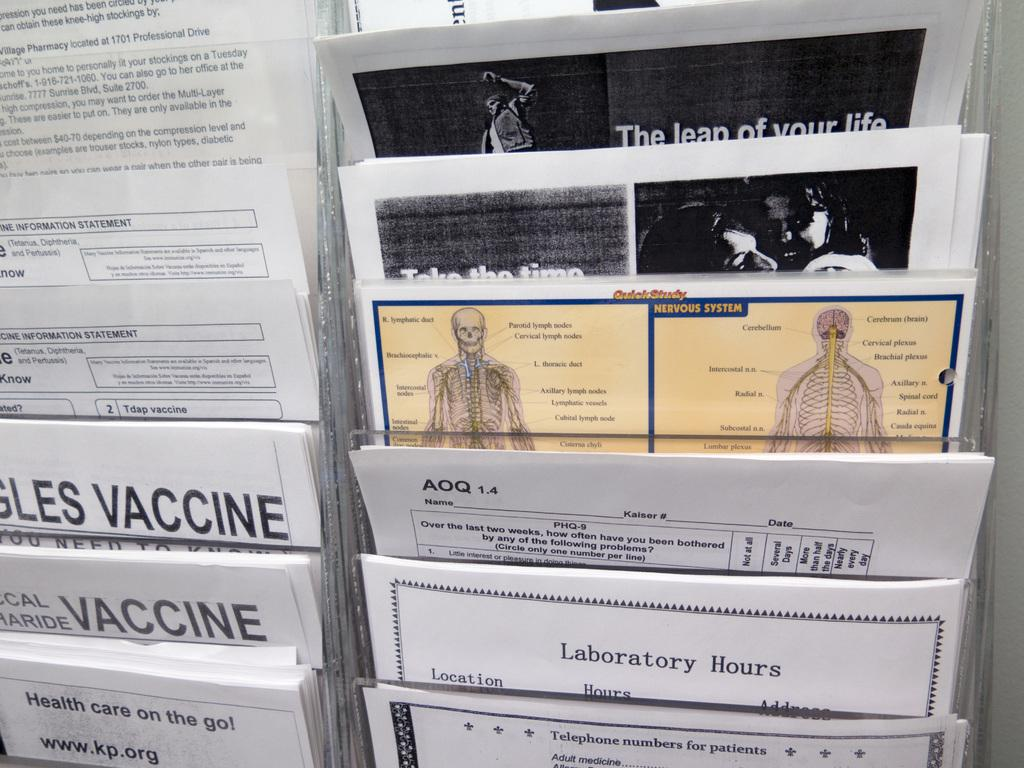What type of objects can be seen in the image? There are printed papers in the image. What can be found on the printed papers? The papers have text and pictures on them. How are the papers arranged in the image? The arrangement of the papers resembles a paper stand. Where is the dock located in the image? There is no dock present in the image. What type of jewel can be seen on the papers in the image? There are no jewels present on the papers in the image; they only have text and pictures. 